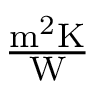Convert formula to latex. <formula><loc_0><loc_0><loc_500><loc_500>\frac { m ^ { 2 } K } { W }</formula> 